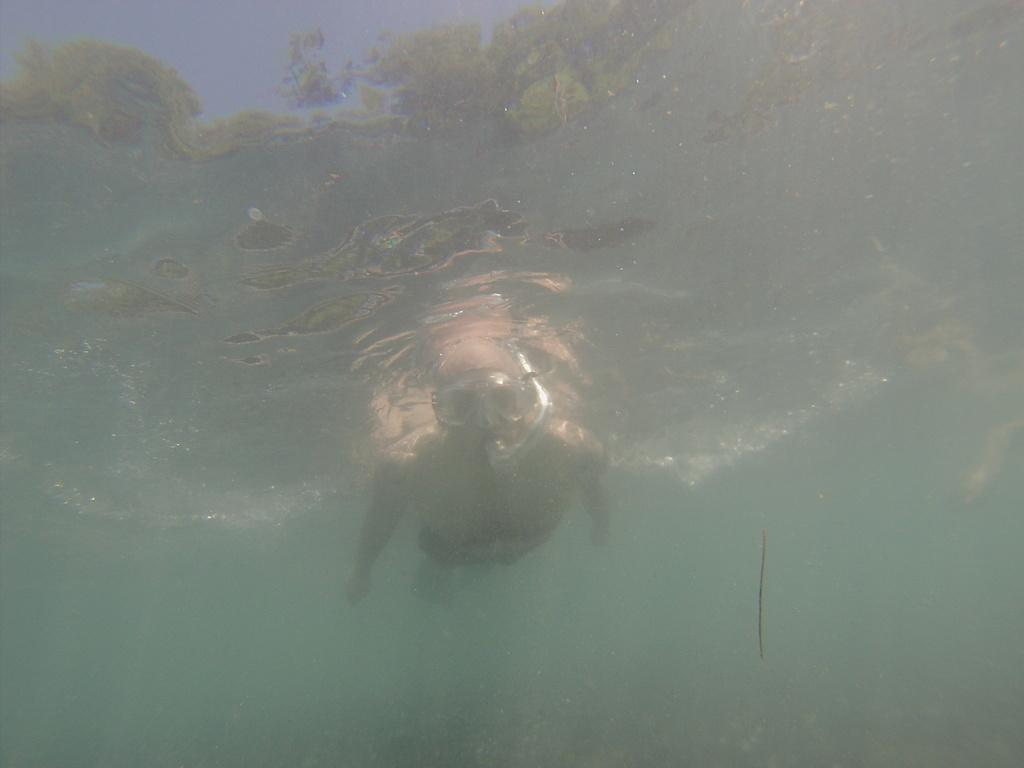Can you describe this image briefly? In this image I see a person who is in the water and I see a thing over here. 